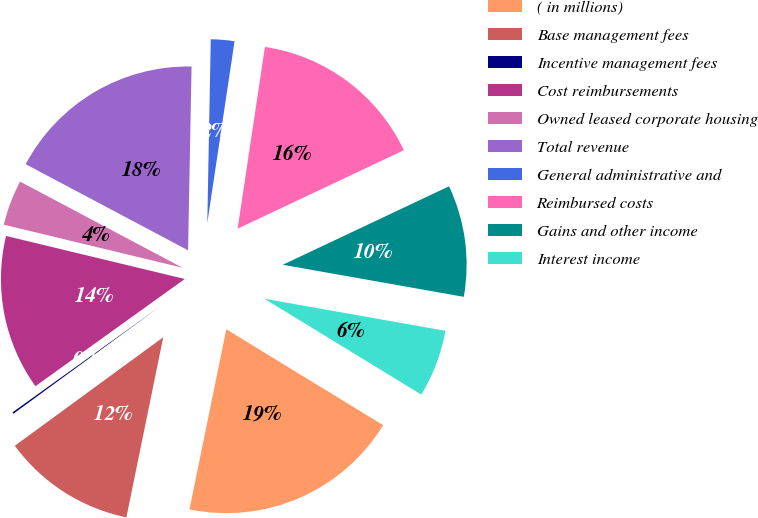Convert chart. <chart><loc_0><loc_0><loc_500><loc_500><pie_chart><fcel>( in millions)<fcel>Base management fees<fcel>Incentive management fees<fcel>Cost reimbursements<fcel>Owned leased corporate housing<fcel>Total revenue<fcel>General administrative and<fcel>Reimbursed costs<fcel>Gains and other income<fcel>Interest income<nl><fcel>19.48%<fcel>11.74%<fcel>0.14%<fcel>13.67%<fcel>4.0%<fcel>17.54%<fcel>2.07%<fcel>15.61%<fcel>9.81%<fcel>5.94%<nl></chart> 